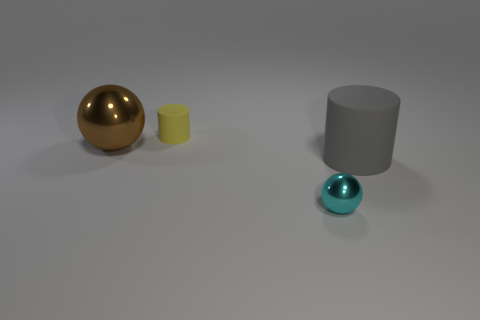Subtract all yellow cylinders. How many cylinders are left? 1 Subtract 2 balls. How many balls are left? 0 Add 1 large rubber cylinders. How many objects exist? 5 Subtract 1 cyan balls. How many objects are left? 3 Subtract all purple cylinders. Subtract all red balls. How many cylinders are left? 2 Subtract all purple cylinders. How many green spheres are left? 0 Subtract all large brown shiny things. Subtract all balls. How many objects are left? 1 Add 4 yellow rubber cylinders. How many yellow rubber cylinders are left? 5 Add 2 yellow cylinders. How many yellow cylinders exist? 3 